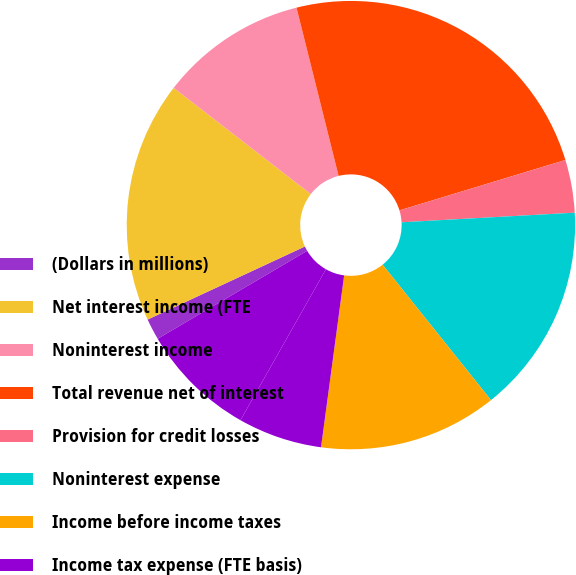Convert chart. <chart><loc_0><loc_0><loc_500><loc_500><pie_chart><fcel>(Dollars in millions)<fcel>Net interest income (FTE<fcel>Noninterest income<fcel>Total revenue net of interest<fcel>Provision for credit losses<fcel>Noninterest expense<fcel>Income before income taxes<fcel>Income tax expense (FTE basis)<fcel>Net income<nl><fcel>1.54%<fcel>17.41%<fcel>10.61%<fcel>24.21%<fcel>3.81%<fcel>15.14%<fcel>12.87%<fcel>6.07%<fcel>8.34%<nl></chart> 